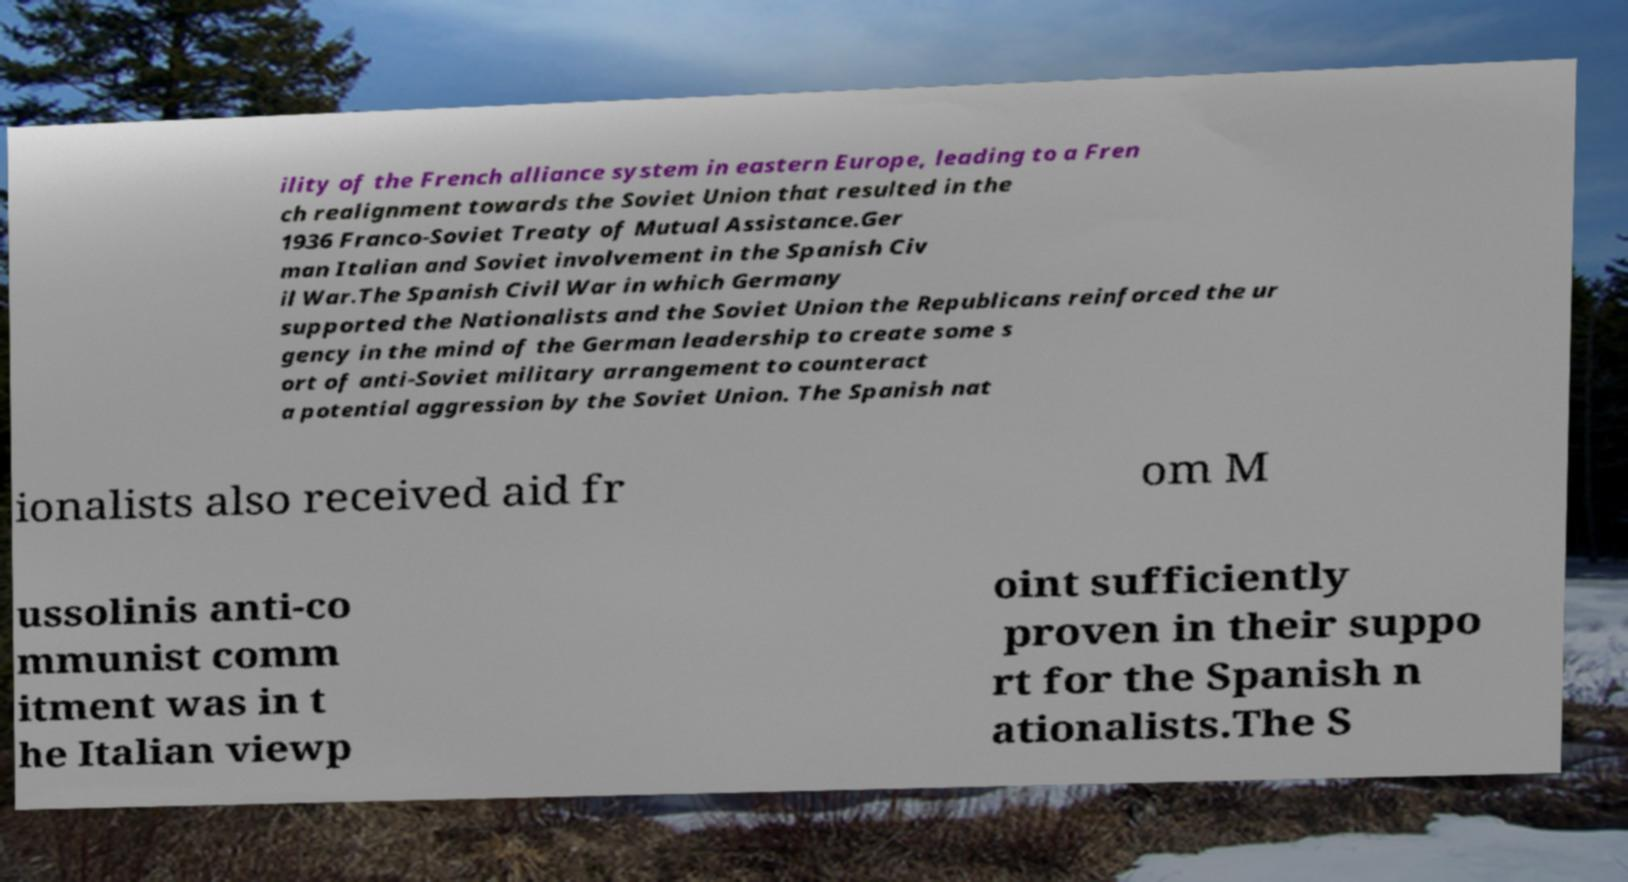Can you accurately transcribe the text from the provided image for me? ility of the French alliance system in eastern Europe, leading to a Fren ch realignment towards the Soviet Union that resulted in the 1936 Franco-Soviet Treaty of Mutual Assistance.Ger man Italian and Soviet involvement in the Spanish Civ il War.The Spanish Civil War in which Germany supported the Nationalists and the Soviet Union the Republicans reinforced the ur gency in the mind of the German leadership to create some s ort of anti-Soviet military arrangement to counteract a potential aggression by the Soviet Union. The Spanish nat ionalists also received aid fr om M ussolinis anti-co mmunist comm itment was in t he Italian viewp oint sufficiently proven in their suppo rt for the Spanish n ationalists.The S 